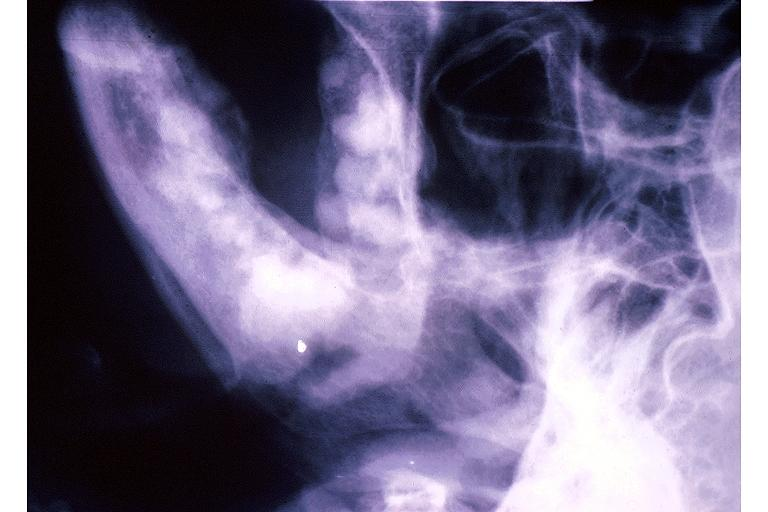where is this?
Answer the question using a single word or phrase. Oral 